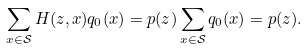<formula> <loc_0><loc_0><loc_500><loc_500>\sum _ { x \in \mathcal { S } } H ( z , x ) q _ { 0 } ( x ) = p ( z ) \sum _ { x \in \mathcal { S } } q _ { 0 } ( x ) = p ( z ) .</formula> 